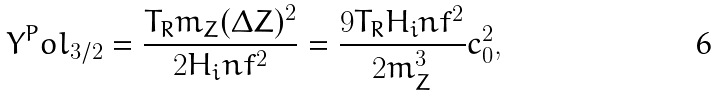Convert formula to latex. <formula><loc_0><loc_0><loc_500><loc_500>Y ^ { P } o l _ { 3 / 2 } = \frac { T _ { R } m _ { Z } ( \Delta Z ) ^ { 2 } } { 2 H _ { i } n f ^ { 2 } } = \frac { 9 T _ { R } H _ { i } n f ^ { 2 } } { 2 m _ { Z } ^ { 3 } } c _ { 0 } ^ { 2 } ,</formula> 